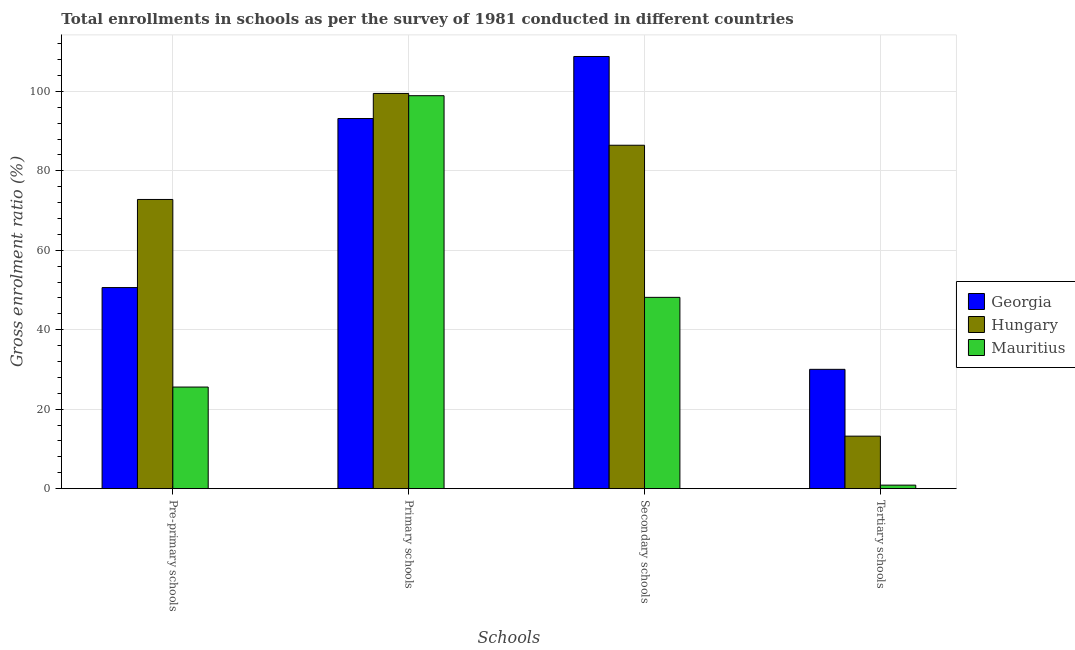Are the number of bars per tick equal to the number of legend labels?
Your answer should be compact. Yes. What is the label of the 2nd group of bars from the left?
Give a very brief answer. Primary schools. What is the gross enrolment ratio in pre-primary schools in Mauritius?
Offer a very short reply. 25.58. Across all countries, what is the maximum gross enrolment ratio in tertiary schools?
Ensure brevity in your answer.  30.04. Across all countries, what is the minimum gross enrolment ratio in tertiary schools?
Offer a very short reply. 0.89. In which country was the gross enrolment ratio in secondary schools maximum?
Your answer should be compact. Georgia. In which country was the gross enrolment ratio in primary schools minimum?
Make the answer very short. Georgia. What is the total gross enrolment ratio in secondary schools in the graph?
Provide a succinct answer. 243.36. What is the difference between the gross enrolment ratio in tertiary schools in Hungary and that in Georgia?
Your response must be concise. -16.82. What is the difference between the gross enrolment ratio in primary schools in Georgia and the gross enrolment ratio in pre-primary schools in Hungary?
Ensure brevity in your answer.  20.37. What is the average gross enrolment ratio in tertiary schools per country?
Your response must be concise. 14.72. What is the difference between the gross enrolment ratio in pre-primary schools and gross enrolment ratio in tertiary schools in Georgia?
Offer a very short reply. 20.58. In how many countries, is the gross enrolment ratio in primary schools greater than 20 %?
Offer a terse response. 3. What is the ratio of the gross enrolment ratio in pre-primary schools in Georgia to that in Mauritius?
Offer a very short reply. 1.98. What is the difference between the highest and the second highest gross enrolment ratio in primary schools?
Your answer should be very brief. 0.57. What is the difference between the highest and the lowest gross enrolment ratio in primary schools?
Provide a short and direct response. 6.31. Is the sum of the gross enrolment ratio in tertiary schools in Hungary and Mauritius greater than the maximum gross enrolment ratio in pre-primary schools across all countries?
Your answer should be compact. No. Is it the case that in every country, the sum of the gross enrolment ratio in tertiary schools and gross enrolment ratio in primary schools is greater than the sum of gross enrolment ratio in pre-primary schools and gross enrolment ratio in secondary schools?
Give a very brief answer. No. What does the 2nd bar from the left in Primary schools represents?
Provide a succinct answer. Hungary. What does the 2nd bar from the right in Tertiary schools represents?
Keep it short and to the point. Hungary. Is it the case that in every country, the sum of the gross enrolment ratio in pre-primary schools and gross enrolment ratio in primary schools is greater than the gross enrolment ratio in secondary schools?
Offer a very short reply. Yes. How many countries are there in the graph?
Your answer should be compact. 3. What is the difference between two consecutive major ticks on the Y-axis?
Provide a succinct answer. 20. Does the graph contain any zero values?
Make the answer very short. No. Does the graph contain grids?
Provide a succinct answer. Yes. Where does the legend appear in the graph?
Offer a terse response. Center right. How are the legend labels stacked?
Provide a short and direct response. Vertical. What is the title of the graph?
Your answer should be very brief. Total enrollments in schools as per the survey of 1981 conducted in different countries. What is the label or title of the X-axis?
Provide a succinct answer. Schools. What is the Gross enrolment ratio (%) of Georgia in Pre-primary schools?
Ensure brevity in your answer.  50.61. What is the Gross enrolment ratio (%) in Hungary in Pre-primary schools?
Provide a succinct answer. 72.79. What is the Gross enrolment ratio (%) of Mauritius in Pre-primary schools?
Ensure brevity in your answer.  25.58. What is the Gross enrolment ratio (%) in Georgia in Primary schools?
Your response must be concise. 93.16. What is the Gross enrolment ratio (%) in Hungary in Primary schools?
Provide a succinct answer. 99.47. What is the Gross enrolment ratio (%) of Mauritius in Primary schools?
Your response must be concise. 98.9. What is the Gross enrolment ratio (%) in Georgia in Secondary schools?
Keep it short and to the point. 108.77. What is the Gross enrolment ratio (%) in Hungary in Secondary schools?
Offer a very short reply. 86.44. What is the Gross enrolment ratio (%) in Mauritius in Secondary schools?
Your response must be concise. 48.15. What is the Gross enrolment ratio (%) of Georgia in Tertiary schools?
Ensure brevity in your answer.  30.04. What is the Gross enrolment ratio (%) of Hungary in Tertiary schools?
Your answer should be compact. 13.22. What is the Gross enrolment ratio (%) in Mauritius in Tertiary schools?
Offer a terse response. 0.89. Across all Schools, what is the maximum Gross enrolment ratio (%) in Georgia?
Offer a very short reply. 108.77. Across all Schools, what is the maximum Gross enrolment ratio (%) of Hungary?
Your answer should be very brief. 99.47. Across all Schools, what is the maximum Gross enrolment ratio (%) of Mauritius?
Your answer should be very brief. 98.9. Across all Schools, what is the minimum Gross enrolment ratio (%) in Georgia?
Provide a short and direct response. 30.04. Across all Schools, what is the minimum Gross enrolment ratio (%) of Hungary?
Provide a short and direct response. 13.22. Across all Schools, what is the minimum Gross enrolment ratio (%) of Mauritius?
Keep it short and to the point. 0.89. What is the total Gross enrolment ratio (%) of Georgia in the graph?
Give a very brief answer. 282.58. What is the total Gross enrolment ratio (%) in Hungary in the graph?
Ensure brevity in your answer.  271.91. What is the total Gross enrolment ratio (%) of Mauritius in the graph?
Your answer should be very brief. 173.52. What is the difference between the Gross enrolment ratio (%) of Georgia in Pre-primary schools and that in Primary schools?
Your answer should be very brief. -42.54. What is the difference between the Gross enrolment ratio (%) in Hungary in Pre-primary schools and that in Primary schools?
Your answer should be very brief. -26.68. What is the difference between the Gross enrolment ratio (%) in Mauritius in Pre-primary schools and that in Primary schools?
Provide a short and direct response. -73.33. What is the difference between the Gross enrolment ratio (%) in Georgia in Pre-primary schools and that in Secondary schools?
Give a very brief answer. -58.16. What is the difference between the Gross enrolment ratio (%) in Hungary in Pre-primary schools and that in Secondary schools?
Offer a very short reply. -13.65. What is the difference between the Gross enrolment ratio (%) in Mauritius in Pre-primary schools and that in Secondary schools?
Provide a succinct answer. -22.57. What is the difference between the Gross enrolment ratio (%) in Georgia in Pre-primary schools and that in Tertiary schools?
Provide a succinct answer. 20.58. What is the difference between the Gross enrolment ratio (%) of Hungary in Pre-primary schools and that in Tertiary schools?
Offer a terse response. 59.57. What is the difference between the Gross enrolment ratio (%) of Mauritius in Pre-primary schools and that in Tertiary schools?
Make the answer very short. 24.69. What is the difference between the Gross enrolment ratio (%) of Georgia in Primary schools and that in Secondary schools?
Provide a short and direct response. -15.62. What is the difference between the Gross enrolment ratio (%) of Hungary in Primary schools and that in Secondary schools?
Your answer should be very brief. 13.03. What is the difference between the Gross enrolment ratio (%) of Mauritius in Primary schools and that in Secondary schools?
Your answer should be very brief. 50.75. What is the difference between the Gross enrolment ratio (%) of Georgia in Primary schools and that in Tertiary schools?
Offer a terse response. 63.12. What is the difference between the Gross enrolment ratio (%) in Hungary in Primary schools and that in Tertiary schools?
Your response must be concise. 86.25. What is the difference between the Gross enrolment ratio (%) of Mauritius in Primary schools and that in Tertiary schools?
Ensure brevity in your answer.  98.01. What is the difference between the Gross enrolment ratio (%) in Georgia in Secondary schools and that in Tertiary schools?
Make the answer very short. 78.74. What is the difference between the Gross enrolment ratio (%) in Hungary in Secondary schools and that in Tertiary schools?
Offer a terse response. 73.22. What is the difference between the Gross enrolment ratio (%) in Mauritius in Secondary schools and that in Tertiary schools?
Give a very brief answer. 47.26. What is the difference between the Gross enrolment ratio (%) in Georgia in Pre-primary schools and the Gross enrolment ratio (%) in Hungary in Primary schools?
Provide a short and direct response. -48.86. What is the difference between the Gross enrolment ratio (%) of Georgia in Pre-primary schools and the Gross enrolment ratio (%) of Mauritius in Primary schools?
Ensure brevity in your answer.  -48.29. What is the difference between the Gross enrolment ratio (%) in Hungary in Pre-primary schools and the Gross enrolment ratio (%) in Mauritius in Primary schools?
Your answer should be very brief. -26.11. What is the difference between the Gross enrolment ratio (%) of Georgia in Pre-primary schools and the Gross enrolment ratio (%) of Hungary in Secondary schools?
Offer a terse response. -35.82. What is the difference between the Gross enrolment ratio (%) in Georgia in Pre-primary schools and the Gross enrolment ratio (%) in Mauritius in Secondary schools?
Provide a short and direct response. 2.46. What is the difference between the Gross enrolment ratio (%) of Hungary in Pre-primary schools and the Gross enrolment ratio (%) of Mauritius in Secondary schools?
Provide a short and direct response. 24.64. What is the difference between the Gross enrolment ratio (%) of Georgia in Pre-primary schools and the Gross enrolment ratio (%) of Hungary in Tertiary schools?
Your answer should be compact. 37.39. What is the difference between the Gross enrolment ratio (%) of Georgia in Pre-primary schools and the Gross enrolment ratio (%) of Mauritius in Tertiary schools?
Your response must be concise. 49.72. What is the difference between the Gross enrolment ratio (%) of Hungary in Pre-primary schools and the Gross enrolment ratio (%) of Mauritius in Tertiary schools?
Give a very brief answer. 71.9. What is the difference between the Gross enrolment ratio (%) in Georgia in Primary schools and the Gross enrolment ratio (%) in Hungary in Secondary schools?
Provide a short and direct response. 6.72. What is the difference between the Gross enrolment ratio (%) of Georgia in Primary schools and the Gross enrolment ratio (%) of Mauritius in Secondary schools?
Your answer should be very brief. 45. What is the difference between the Gross enrolment ratio (%) in Hungary in Primary schools and the Gross enrolment ratio (%) in Mauritius in Secondary schools?
Your answer should be very brief. 51.32. What is the difference between the Gross enrolment ratio (%) of Georgia in Primary schools and the Gross enrolment ratio (%) of Hungary in Tertiary schools?
Your response must be concise. 79.94. What is the difference between the Gross enrolment ratio (%) of Georgia in Primary schools and the Gross enrolment ratio (%) of Mauritius in Tertiary schools?
Provide a short and direct response. 92.27. What is the difference between the Gross enrolment ratio (%) of Hungary in Primary schools and the Gross enrolment ratio (%) of Mauritius in Tertiary schools?
Keep it short and to the point. 98.58. What is the difference between the Gross enrolment ratio (%) in Georgia in Secondary schools and the Gross enrolment ratio (%) in Hungary in Tertiary schools?
Provide a succinct answer. 95.55. What is the difference between the Gross enrolment ratio (%) of Georgia in Secondary schools and the Gross enrolment ratio (%) of Mauritius in Tertiary schools?
Your answer should be very brief. 107.88. What is the difference between the Gross enrolment ratio (%) of Hungary in Secondary schools and the Gross enrolment ratio (%) of Mauritius in Tertiary schools?
Your answer should be compact. 85.54. What is the average Gross enrolment ratio (%) of Georgia per Schools?
Make the answer very short. 70.64. What is the average Gross enrolment ratio (%) in Hungary per Schools?
Keep it short and to the point. 67.98. What is the average Gross enrolment ratio (%) in Mauritius per Schools?
Offer a terse response. 43.38. What is the difference between the Gross enrolment ratio (%) of Georgia and Gross enrolment ratio (%) of Hungary in Pre-primary schools?
Your answer should be very brief. -22.18. What is the difference between the Gross enrolment ratio (%) in Georgia and Gross enrolment ratio (%) in Mauritius in Pre-primary schools?
Offer a very short reply. 25.04. What is the difference between the Gross enrolment ratio (%) of Hungary and Gross enrolment ratio (%) of Mauritius in Pre-primary schools?
Give a very brief answer. 47.21. What is the difference between the Gross enrolment ratio (%) of Georgia and Gross enrolment ratio (%) of Hungary in Primary schools?
Ensure brevity in your answer.  -6.31. What is the difference between the Gross enrolment ratio (%) in Georgia and Gross enrolment ratio (%) in Mauritius in Primary schools?
Offer a very short reply. -5.75. What is the difference between the Gross enrolment ratio (%) in Hungary and Gross enrolment ratio (%) in Mauritius in Primary schools?
Your response must be concise. 0.57. What is the difference between the Gross enrolment ratio (%) of Georgia and Gross enrolment ratio (%) of Hungary in Secondary schools?
Make the answer very short. 22.34. What is the difference between the Gross enrolment ratio (%) in Georgia and Gross enrolment ratio (%) in Mauritius in Secondary schools?
Your answer should be compact. 60.62. What is the difference between the Gross enrolment ratio (%) in Hungary and Gross enrolment ratio (%) in Mauritius in Secondary schools?
Your response must be concise. 38.28. What is the difference between the Gross enrolment ratio (%) of Georgia and Gross enrolment ratio (%) of Hungary in Tertiary schools?
Your answer should be very brief. 16.82. What is the difference between the Gross enrolment ratio (%) of Georgia and Gross enrolment ratio (%) of Mauritius in Tertiary schools?
Give a very brief answer. 29.15. What is the difference between the Gross enrolment ratio (%) in Hungary and Gross enrolment ratio (%) in Mauritius in Tertiary schools?
Give a very brief answer. 12.33. What is the ratio of the Gross enrolment ratio (%) in Georgia in Pre-primary schools to that in Primary schools?
Keep it short and to the point. 0.54. What is the ratio of the Gross enrolment ratio (%) in Hungary in Pre-primary schools to that in Primary schools?
Keep it short and to the point. 0.73. What is the ratio of the Gross enrolment ratio (%) of Mauritius in Pre-primary schools to that in Primary schools?
Give a very brief answer. 0.26. What is the ratio of the Gross enrolment ratio (%) in Georgia in Pre-primary schools to that in Secondary schools?
Keep it short and to the point. 0.47. What is the ratio of the Gross enrolment ratio (%) of Hungary in Pre-primary schools to that in Secondary schools?
Make the answer very short. 0.84. What is the ratio of the Gross enrolment ratio (%) of Mauritius in Pre-primary schools to that in Secondary schools?
Your response must be concise. 0.53. What is the ratio of the Gross enrolment ratio (%) in Georgia in Pre-primary schools to that in Tertiary schools?
Your response must be concise. 1.69. What is the ratio of the Gross enrolment ratio (%) in Hungary in Pre-primary schools to that in Tertiary schools?
Make the answer very short. 5.51. What is the ratio of the Gross enrolment ratio (%) in Mauritius in Pre-primary schools to that in Tertiary schools?
Give a very brief answer. 28.71. What is the ratio of the Gross enrolment ratio (%) of Georgia in Primary schools to that in Secondary schools?
Your answer should be compact. 0.86. What is the ratio of the Gross enrolment ratio (%) of Hungary in Primary schools to that in Secondary schools?
Make the answer very short. 1.15. What is the ratio of the Gross enrolment ratio (%) in Mauritius in Primary schools to that in Secondary schools?
Make the answer very short. 2.05. What is the ratio of the Gross enrolment ratio (%) in Georgia in Primary schools to that in Tertiary schools?
Give a very brief answer. 3.1. What is the ratio of the Gross enrolment ratio (%) of Hungary in Primary schools to that in Tertiary schools?
Make the answer very short. 7.52. What is the ratio of the Gross enrolment ratio (%) of Mauritius in Primary schools to that in Tertiary schools?
Offer a very short reply. 111.02. What is the ratio of the Gross enrolment ratio (%) of Georgia in Secondary schools to that in Tertiary schools?
Your answer should be compact. 3.62. What is the ratio of the Gross enrolment ratio (%) in Hungary in Secondary schools to that in Tertiary schools?
Your answer should be compact. 6.54. What is the ratio of the Gross enrolment ratio (%) in Mauritius in Secondary schools to that in Tertiary schools?
Your response must be concise. 54.05. What is the difference between the highest and the second highest Gross enrolment ratio (%) of Georgia?
Offer a very short reply. 15.62. What is the difference between the highest and the second highest Gross enrolment ratio (%) of Hungary?
Offer a terse response. 13.03. What is the difference between the highest and the second highest Gross enrolment ratio (%) of Mauritius?
Ensure brevity in your answer.  50.75. What is the difference between the highest and the lowest Gross enrolment ratio (%) of Georgia?
Your answer should be very brief. 78.74. What is the difference between the highest and the lowest Gross enrolment ratio (%) of Hungary?
Provide a short and direct response. 86.25. What is the difference between the highest and the lowest Gross enrolment ratio (%) of Mauritius?
Your answer should be compact. 98.01. 